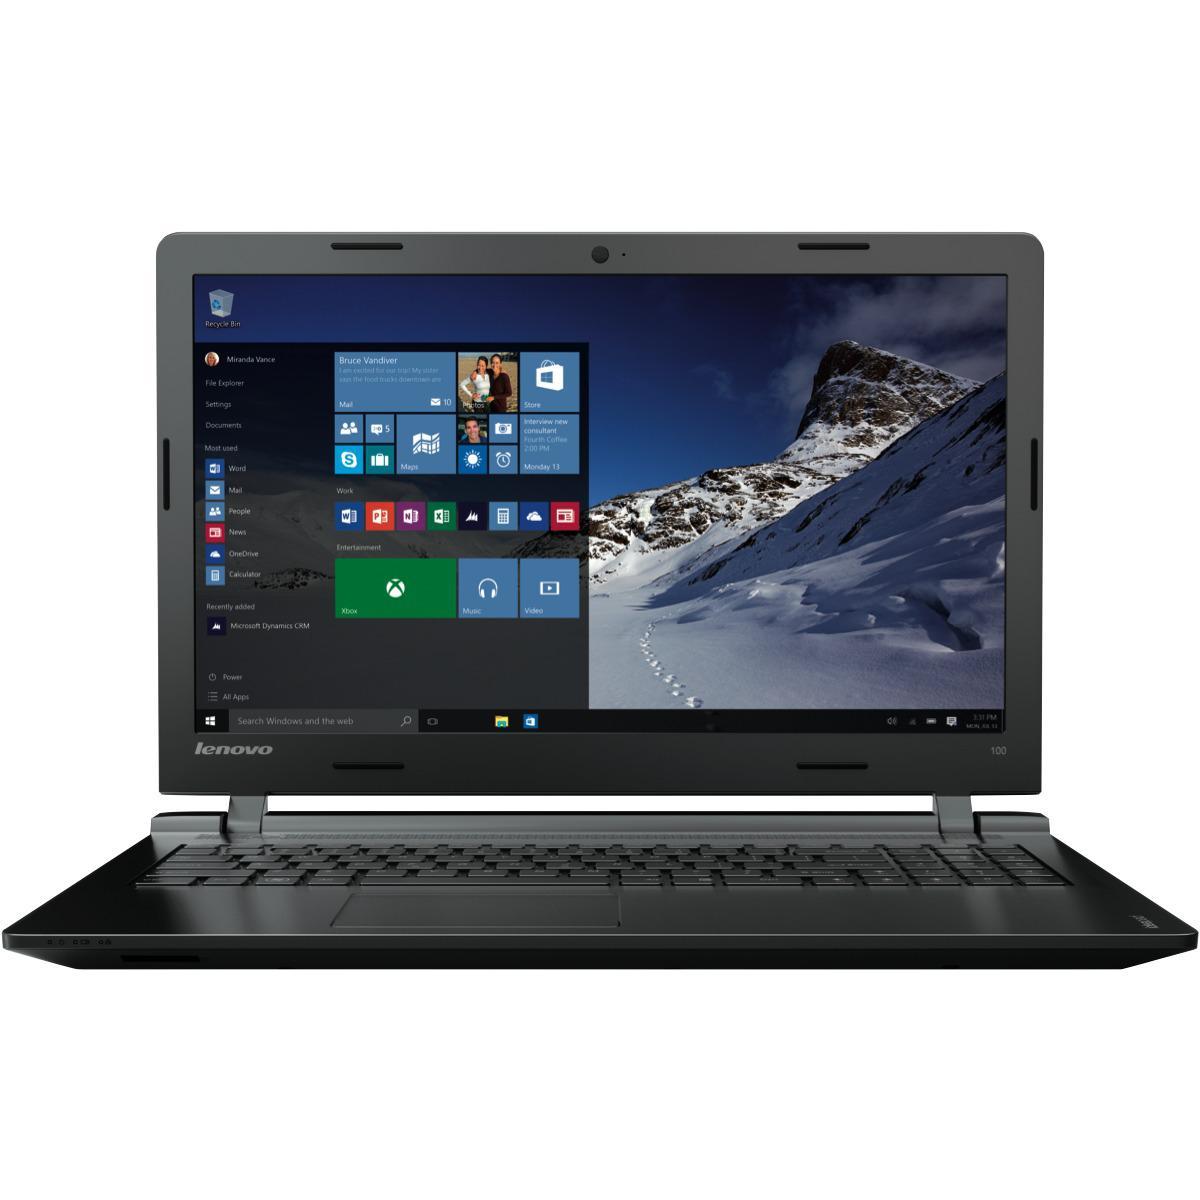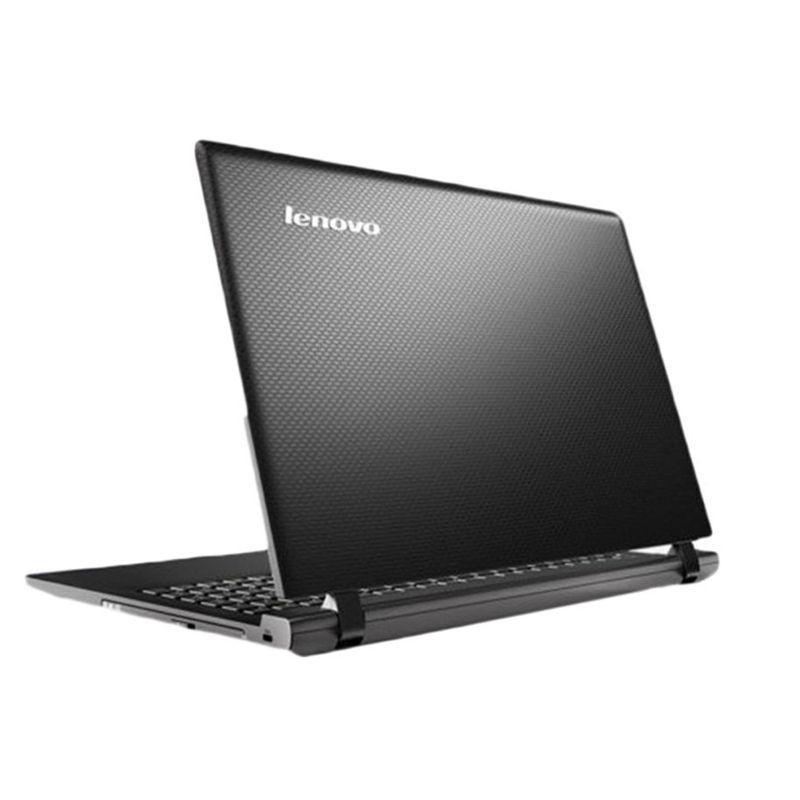The first image is the image on the left, the second image is the image on the right. Evaluate the accuracy of this statement regarding the images: "Each image contains one laptop opened to at least 90-degrees with its screen visible.". Is it true? Answer yes or no. No. The first image is the image on the left, the second image is the image on the right. For the images shown, is this caption "One of the displays shows a mountain." true? Answer yes or no. Yes. 